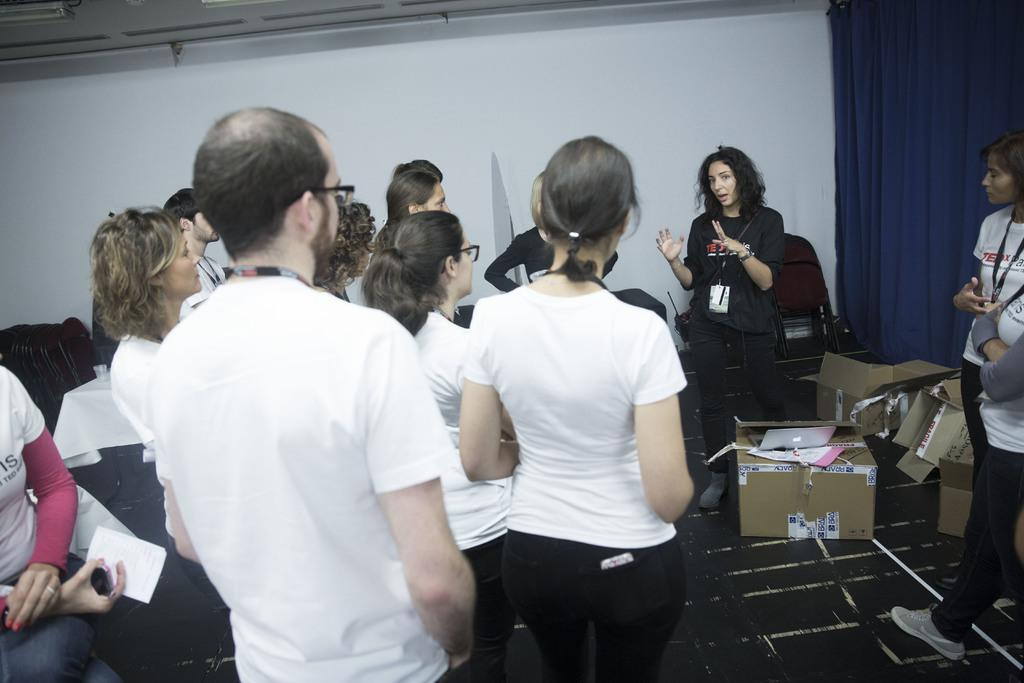Who or what can be seen in the image? There are people in the image. What objects are present in the image besides the people? There are carton boxes and chairs in the image. What type of window treatment is visible in the image? There is a curtain in the image. What can be seen in the background of the image? There is a wall in the background of the image. How many rabbits can be seen hopping on the wall in the image? There are no rabbits present in the image; only people, carton boxes, chairs, a curtain, and a wall can be seen. 